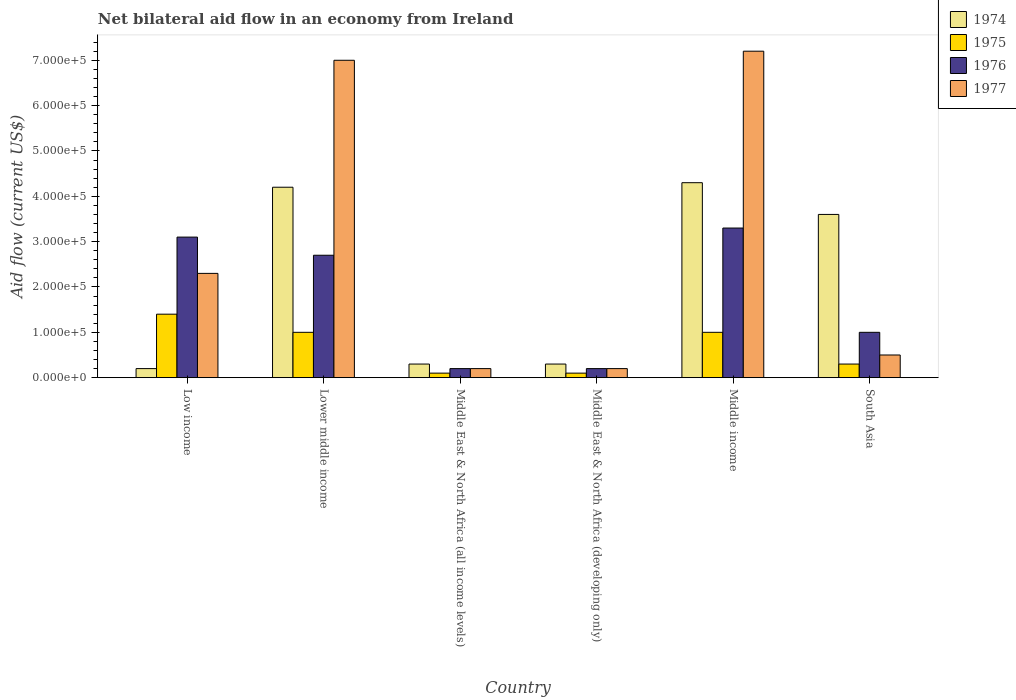How many different coloured bars are there?
Your answer should be compact. 4. How many groups of bars are there?
Offer a very short reply. 6. Are the number of bars per tick equal to the number of legend labels?
Your answer should be compact. Yes. Are the number of bars on each tick of the X-axis equal?
Keep it short and to the point. Yes. How many bars are there on the 6th tick from the right?
Offer a terse response. 4. What is the label of the 4th group of bars from the left?
Your answer should be very brief. Middle East & North Africa (developing only). What is the net bilateral aid flow in 1974 in Lower middle income?
Your response must be concise. 4.20e+05. Across all countries, what is the maximum net bilateral aid flow in 1975?
Give a very brief answer. 1.40e+05. In which country was the net bilateral aid flow in 1976 minimum?
Provide a succinct answer. Middle East & North Africa (all income levels). What is the total net bilateral aid flow in 1977 in the graph?
Provide a succinct answer. 1.74e+06. What is the average net bilateral aid flow in 1976 per country?
Offer a very short reply. 1.75e+05. What is the ratio of the net bilateral aid flow in 1976 in Middle East & North Africa (all income levels) to that in Middle income?
Keep it short and to the point. 0.06. Is the difference between the net bilateral aid flow in 1974 in Middle East & North Africa (developing only) and South Asia greater than the difference between the net bilateral aid flow in 1975 in Middle East & North Africa (developing only) and South Asia?
Make the answer very short. No. Is the sum of the net bilateral aid flow in 1975 in Middle East & North Africa (developing only) and South Asia greater than the maximum net bilateral aid flow in 1974 across all countries?
Ensure brevity in your answer.  No. What does the 4th bar from the left in Middle East & North Africa (all income levels) represents?
Your answer should be very brief. 1977. What does the 4th bar from the right in South Asia represents?
Provide a short and direct response. 1974. Is it the case that in every country, the sum of the net bilateral aid flow in 1976 and net bilateral aid flow in 1977 is greater than the net bilateral aid flow in 1975?
Your response must be concise. Yes. Are all the bars in the graph horizontal?
Offer a very short reply. No. What is the difference between two consecutive major ticks on the Y-axis?
Your response must be concise. 1.00e+05. Are the values on the major ticks of Y-axis written in scientific E-notation?
Your response must be concise. Yes. How many legend labels are there?
Provide a short and direct response. 4. What is the title of the graph?
Ensure brevity in your answer.  Net bilateral aid flow in an economy from Ireland. What is the label or title of the Y-axis?
Make the answer very short. Aid flow (current US$). What is the Aid flow (current US$) of 1976 in Low income?
Ensure brevity in your answer.  3.10e+05. What is the Aid flow (current US$) in 1974 in Lower middle income?
Your answer should be very brief. 4.20e+05. What is the Aid flow (current US$) of 1975 in Middle East & North Africa (all income levels)?
Ensure brevity in your answer.  10000. What is the Aid flow (current US$) of 1976 in Middle East & North Africa (all income levels)?
Your answer should be compact. 2.00e+04. What is the Aid flow (current US$) in 1977 in Middle East & North Africa (all income levels)?
Keep it short and to the point. 2.00e+04. What is the Aid flow (current US$) in 1976 in Middle East & North Africa (developing only)?
Your response must be concise. 2.00e+04. What is the Aid flow (current US$) of 1974 in Middle income?
Your answer should be compact. 4.30e+05. What is the Aid flow (current US$) in 1975 in Middle income?
Ensure brevity in your answer.  1.00e+05. What is the Aid flow (current US$) of 1976 in Middle income?
Give a very brief answer. 3.30e+05. What is the Aid flow (current US$) of 1977 in Middle income?
Offer a terse response. 7.20e+05. What is the Aid flow (current US$) in 1975 in South Asia?
Offer a terse response. 3.00e+04. What is the Aid flow (current US$) in 1976 in South Asia?
Your response must be concise. 1.00e+05. Across all countries, what is the maximum Aid flow (current US$) of 1977?
Provide a short and direct response. 7.20e+05. Across all countries, what is the minimum Aid flow (current US$) in 1974?
Your answer should be very brief. 2.00e+04. Across all countries, what is the minimum Aid flow (current US$) in 1976?
Your answer should be very brief. 2.00e+04. What is the total Aid flow (current US$) in 1974 in the graph?
Provide a succinct answer. 1.29e+06. What is the total Aid flow (current US$) in 1976 in the graph?
Your response must be concise. 1.05e+06. What is the total Aid flow (current US$) of 1977 in the graph?
Make the answer very short. 1.74e+06. What is the difference between the Aid flow (current US$) of 1974 in Low income and that in Lower middle income?
Your answer should be very brief. -4.00e+05. What is the difference between the Aid flow (current US$) in 1976 in Low income and that in Lower middle income?
Keep it short and to the point. 4.00e+04. What is the difference between the Aid flow (current US$) of 1977 in Low income and that in Lower middle income?
Offer a very short reply. -4.70e+05. What is the difference between the Aid flow (current US$) of 1975 in Low income and that in Middle East & North Africa (all income levels)?
Offer a very short reply. 1.30e+05. What is the difference between the Aid flow (current US$) in 1977 in Low income and that in Middle East & North Africa (all income levels)?
Give a very brief answer. 2.10e+05. What is the difference between the Aid flow (current US$) of 1974 in Low income and that in Middle income?
Keep it short and to the point. -4.10e+05. What is the difference between the Aid flow (current US$) in 1977 in Low income and that in Middle income?
Provide a short and direct response. -4.90e+05. What is the difference between the Aid flow (current US$) of 1975 in Low income and that in South Asia?
Make the answer very short. 1.10e+05. What is the difference between the Aid flow (current US$) in 1976 in Low income and that in South Asia?
Give a very brief answer. 2.10e+05. What is the difference between the Aid flow (current US$) of 1977 in Low income and that in South Asia?
Provide a short and direct response. 1.80e+05. What is the difference between the Aid flow (current US$) of 1976 in Lower middle income and that in Middle East & North Africa (all income levels)?
Provide a succinct answer. 2.50e+05. What is the difference between the Aid flow (current US$) in 1977 in Lower middle income and that in Middle East & North Africa (all income levels)?
Your answer should be compact. 6.80e+05. What is the difference between the Aid flow (current US$) in 1974 in Lower middle income and that in Middle East & North Africa (developing only)?
Make the answer very short. 3.90e+05. What is the difference between the Aid flow (current US$) in 1975 in Lower middle income and that in Middle East & North Africa (developing only)?
Your response must be concise. 9.00e+04. What is the difference between the Aid flow (current US$) of 1976 in Lower middle income and that in Middle East & North Africa (developing only)?
Keep it short and to the point. 2.50e+05. What is the difference between the Aid flow (current US$) in 1977 in Lower middle income and that in Middle East & North Africa (developing only)?
Make the answer very short. 6.80e+05. What is the difference between the Aid flow (current US$) of 1975 in Lower middle income and that in Middle income?
Provide a short and direct response. 0. What is the difference between the Aid flow (current US$) of 1976 in Lower middle income and that in South Asia?
Keep it short and to the point. 1.70e+05. What is the difference between the Aid flow (current US$) of 1977 in Lower middle income and that in South Asia?
Provide a succinct answer. 6.50e+05. What is the difference between the Aid flow (current US$) of 1975 in Middle East & North Africa (all income levels) and that in Middle East & North Africa (developing only)?
Your response must be concise. 0. What is the difference between the Aid flow (current US$) in 1976 in Middle East & North Africa (all income levels) and that in Middle East & North Africa (developing only)?
Offer a very short reply. 0. What is the difference between the Aid flow (current US$) of 1974 in Middle East & North Africa (all income levels) and that in Middle income?
Make the answer very short. -4.00e+05. What is the difference between the Aid flow (current US$) in 1976 in Middle East & North Africa (all income levels) and that in Middle income?
Your response must be concise. -3.10e+05. What is the difference between the Aid flow (current US$) in 1977 in Middle East & North Africa (all income levels) and that in Middle income?
Give a very brief answer. -7.00e+05. What is the difference between the Aid flow (current US$) in 1974 in Middle East & North Africa (all income levels) and that in South Asia?
Offer a very short reply. -3.30e+05. What is the difference between the Aid flow (current US$) in 1975 in Middle East & North Africa (all income levels) and that in South Asia?
Ensure brevity in your answer.  -2.00e+04. What is the difference between the Aid flow (current US$) in 1977 in Middle East & North Africa (all income levels) and that in South Asia?
Your answer should be very brief. -3.00e+04. What is the difference between the Aid flow (current US$) of 1974 in Middle East & North Africa (developing only) and that in Middle income?
Provide a short and direct response. -4.00e+05. What is the difference between the Aid flow (current US$) in 1975 in Middle East & North Africa (developing only) and that in Middle income?
Offer a terse response. -9.00e+04. What is the difference between the Aid flow (current US$) in 1976 in Middle East & North Africa (developing only) and that in Middle income?
Your answer should be very brief. -3.10e+05. What is the difference between the Aid flow (current US$) in 1977 in Middle East & North Africa (developing only) and that in Middle income?
Keep it short and to the point. -7.00e+05. What is the difference between the Aid flow (current US$) in 1974 in Middle East & North Africa (developing only) and that in South Asia?
Offer a terse response. -3.30e+05. What is the difference between the Aid flow (current US$) of 1977 in Middle East & North Africa (developing only) and that in South Asia?
Your response must be concise. -3.00e+04. What is the difference between the Aid flow (current US$) in 1975 in Middle income and that in South Asia?
Your answer should be compact. 7.00e+04. What is the difference between the Aid flow (current US$) of 1977 in Middle income and that in South Asia?
Offer a terse response. 6.70e+05. What is the difference between the Aid flow (current US$) in 1974 in Low income and the Aid flow (current US$) in 1976 in Lower middle income?
Offer a terse response. -2.50e+05. What is the difference between the Aid flow (current US$) of 1974 in Low income and the Aid flow (current US$) of 1977 in Lower middle income?
Your response must be concise. -6.80e+05. What is the difference between the Aid flow (current US$) in 1975 in Low income and the Aid flow (current US$) in 1977 in Lower middle income?
Your response must be concise. -5.60e+05. What is the difference between the Aid flow (current US$) of 1976 in Low income and the Aid flow (current US$) of 1977 in Lower middle income?
Your answer should be compact. -3.90e+05. What is the difference between the Aid flow (current US$) in 1974 in Low income and the Aid flow (current US$) in 1975 in Middle East & North Africa (all income levels)?
Offer a very short reply. 10000. What is the difference between the Aid flow (current US$) in 1974 in Low income and the Aid flow (current US$) in 1977 in Middle East & North Africa (all income levels)?
Offer a terse response. 0. What is the difference between the Aid flow (current US$) in 1976 in Low income and the Aid flow (current US$) in 1977 in Middle East & North Africa (all income levels)?
Offer a terse response. 2.90e+05. What is the difference between the Aid flow (current US$) of 1974 in Low income and the Aid flow (current US$) of 1975 in Middle East & North Africa (developing only)?
Your answer should be compact. 10000. What is the difference between the Aid flow (current US$) in 1974 in Low income and the Aid flow (current US$) in 1976 in Middle East & North Africa (developing only)?
Your answer should be compact. 0. What is the difference between the Aid flow (current US$) in 1974 in Low income and the Aid flow (current US$) in 1977 in Middle East & North Africa (developing only)?
Your response must be concise. 0. What is the difference between the Aid flow (current US$) in 1975 in Low income and the Aid flow (current US$) in 1976 in Middle East & North Africa (developing only)?
Your answer should be compact. 1.20e+05. What is the difference between the Aid flow (current US$) in 1975 in Low income and the Aid flow (current US$) in 1977 in Middle East & North Africa (developing only)?
Provide a short and direct response. 1.20e+05. What is the difference between the Aid flow (current US$) in 1976 in Low income and the Aid flow (current US$) in 1977 in Middle East & North Africa (developing only)?
Keep it short and to the point. 2.90e+05. What is the difference between the Aid flow (current US$) in 1974 in Low income and the Aid flow (current US$) in 1975 in Middle income?
Your answer should be compact. -8.00e+04. What is the difference between the Aid flow (current US$) in 1974 in Low income and the Aid flow (current US$) in 1976 in Middle income?
Ensure brevity in your answer.  -3.10e+05. What is the difference between the Aid flow (current US$) of 1974 in Low income and the Aid flow (current US$) of 1977 in Middle income?
Your answer should be very brief. -7.00e+05. What is the difference between the Aid flow (current US$) in 1975 in Low income and the Aid flow (current US$) in 1977 in Middle income?
Offer a very short reply. -5.80e+05. What is the difference between the Aid flow (current US$) of 1976 in Low income and the Aid flow (current US$) of 1977 in Middle income?
Your response must be concise. -4.10e+05. What is the difference between the Aid flow (current US$) of 1974 in Low income and the Aid flow (current US$) of 1975 in South Asia?
Provide a succinct answer. -10000. What is the difference between the Aid flow (current US$) in 1975 in Low income and the Aid flow (current US$) in 1976 in South Asia?
Your answer should be compact. 4.00e+04. What is the difference between the Aid flow (current US$) in 1975 in Low income and the Aid flow (current US$) in 1977 in South Asia?
Provide a succinct answer. 9.00e+04. What is the difference between the Aid flow (current US$) of 1976 in Low income and the Aid flow (current US$) of 1977 in South Asia?
Provide a succinct answer. 2.60e+05. What is the difference between the Aid flow (current US$) in 1974 in Lower middle income and the Aid flow (current US$) in 1976 in Middle East & North Africa (all income levels)?
Make the answer very short. 4.00e+05. What is the difference between the Aid flow (current US$) in 1975 in Lower middle income and the Aid flow (current US$) in 1976 in Middle East & North Africa (all income levels)?
Ensure brevity in your answer.  8.00e+04. What is the difference between the Aid flow (current US$) in 1974 in Lower middle income and the Aid flow (current US$) in 1975 in Middle East & North Africa (developing only)?
Offer a very short reply. 4.10e+05. What is the difference between the Aid flow (current US$) of 1974 in Lower middle income and the Aid flow (current US$) of 1976 in Middle East & North Africa (developing only)?
Your answer should be very brief. 4.00e+05. What is the difference between the Aid flow (current US$) of 1975 in Lower middle income and the Aid flow (current US$) of 1976 in Middle East & North Africa (developing only)?
Your response must be concise. 8.00e+04. What is the difference between the Aid flow (current US$) of 1975 in Lower middle income and the Aid flow (current US$) of 1977 in Middle East & North Africa (developing only)?
Provide a short and direct response. 8.00e+04. What is the difference between the Aid flow (current US$) of 1974 in Lower middle income and the Aid flow (current US$) of 1976 in Middle income?
Your answer should be very brief. 9.00e+04. What is the difference between the Aid flow (current US$) of 1975 in Lower middle income and the Aid flow (current US$) of 1977 in Middle income?
Ensure brevity in your answer.  -6.20e+05. What is the difference between the Aid flow (current US$) of 1976 in Lower middle income and the Aid flow (current US$) of 1977 in Middle income?
Your answer should be very brief. -4.50e+05. What is the difference between the Aid flow (current US$) in 1974 in Lower middle income and the Aid flow (current US$) in 1975 in South Asia?
Give a very brief answer. 3.90e+05. What is the difference between the Aid flow (current US$) of 1975 in Lower middle income and the Aid flow (current US$) of 1976 in South Asia?
Make the answer very short. 0. What is the difference between the Aid flow (current US$) of 1975 in Lower middle income and the Aid flow (current US$) of 1977 in South Asia?
Your answer should be very brief. 5.00e+04. What is the difference between the Aid flow (current US$) in 1976 in Lower middle income and the Aid flow (current US$) in 1977 in South Asia?
Ensure brevity in your answer.  2.20e+05. What is the difference between the Aid flow (current US$) of 1974 in Middle East & North Africa (all income levels) and the Aid flow (current US$) of 1975 in Middle East & North Africa (developing only)?
Offer a very short reply. 2.00e+04. What is the difference between the Aid flow (current US$) in 1975 in Middle East & North Africa (all income levels) and the Aid flow (current US$) in 1977 in Middle East & North Africa (developing only)?
Ensure brevity in your answer.  -10000. What is the difference between the Aid flow (current US$) of 1974 in Middle East & North Africa (all income levels) and the Aid flow (current US$) of 1977 in Middle income?
Offer a very short reply. -6.90e+05. What is the difference between the Aid flow (current US$) in 1975 in Middle East & North Africa (all income levels) and the Aid flow (current US$) in 1976 in Middle income?
Offer a terse response. -3.20e+05. What is the difference between the Aid flow (current US$) in 1975 in Middle East & North Africa (all income levels) and the Aid flow (current US$) in 1977 in Middle income?
Ensure brevity in your answer.  -7.10e+05. What is the difference between the Aid flow (current US$) of 1976 in Middle East & North Africa (all income levels) and the Aid flow (current US$) of 1977 in Middle income?
Your answer should be very brief. -7.00e+05. What is the difference between the Aid flow (current US$) in 1974 in Middle East & North Africa (all income levels) and the Aid flow (current US$) in 1975 in South Asia?
Keep it short and to the point. 0. What is the difference between the Aid flow (current US$) in 1974 in Middle East & North Africa (all income levels) and the Aid flow (current US$) in 1976 in South Asia?
Provide a short and direct response. -7.00e+04. What is the difference between the Aid flow (current US$) in 1974 in Middle East & North Africa (all income levels) and the Aid flow (current US$) in 1977 in South Asia?
Offer a very short reply. -2.00e+04. What is the difference between the Aid flow (current US$) in 1975 in Middle East & North Africa (all income levels) and the Aid flow (current US$) in 1976 in South Asia?
Your answer should be very brief. -9.00e+04. What is the difference between the Aid flow (current US$) of 1975 in Middle East & North Africa (all income levels) and the Aid flow (current US$) of 1977 in South Asia?
Your answer should be very brief. -4.00e+04. What is the difference between the Aid flow (current US$) of 1976 in Middle East & North Africa (all income levels) and the Aid flow (current US$) of 1977 in South Asia?
Ensure brevity in your answer.  -3.00e+04. What is the difference between the Aid flow (current US$) of 1974 in Middle East & North Africa (developing only) and the Aid flow (current US$) of 1975 in Middle income?
Your response must be concise. -7.00e+04. What is the difference between the Aid flow (current US$) of 1974 in Middle East & North Africa (developing only) and the Aid flow (current US$) of 1976 in Middle income?
Give a very brief answer. -3.00e+05. What is the difference between the Aid flow (current US$) of 1974 in Middle East & North Africa (developing only) and the Aid flow (current US$) of 1977 in Middle income?
Your response must be concise. -6.90e+05. What is the difference between the Aid flow (current US$) in 1975 in Middle East & North Africa (developing only) and the Aid flow (current US$) in 1976 in Middle income?
Your answer should be very brief. -3.20e+05. What is the difference between the Aid flow (current US$) in 1975 in Middle East & North Africa (developing only) and the Aid flow (current US$) in 1977 in Middle income?
Make the answer very short. -7.10e+05. What is the difference between the Aid flow (current US$) in 1976 in Middle East & North Africa (developing only) and the Aid flow (current US$) in 1977 in Middle income?
Offer a terse response. -7.00e+05. What is the difference between the Aid flow (current US$) in 1974 in Middle East & North Africa (developing only) and the Aid flow (current US$) in 1975 in South Asia?
Your answer should be very brief. 0. What is the difference between the Aid flow (current US$) in 1974 in Middle East & North Africa (developing only) and the Aid flow (current US$) in 1976 in South Asia?
Give a very brief answer. -7.00e+04. What is the difference between the Aid flow (current US$) of 1974 in Middle East & North Africa (developing only) and the Aid flow (current US$) of 1977 in South Asia?
Your response must be concise. -2.00e+04. What is the difference between the Aid flow (current US$) in 1975 in Middle income and the Aid flow (current US$) in 1976 in South Asia?
Your response must be concise. 0. What is the difference between the Aid flow (current US$) of 1975 in Middle income and the Aid flow (current US$) of 1977 in South Asia?
Keep it short and to the point. 5.00e+04. What is the average Aid flow (current US$) in 1974 per country?
Give a very brief answer. 2.15e+05. What is the average Aid flow (current US$) of 1975 per country?
Your answer should be compact. 6.50e+04. What is the average Aid flow (current US$) of 1976 per country?
Your answer should be very brief. 1.75e+05. What is the average Aid flow (current US$) in 1977 per country?
Your response must be concise. 2.90e+05. What is the difference between the Aid flow (current US$) in 1974 and Aid flow (current US$) in 1976 in Low income?
Offer a very short reply. -2.90e+05. What is the difference between the Aid flow (current US$) in 1974 and Aid flow (current US$) in 1977 in Low income?
Provide a short and direct response. -2.10e+05. What is the difference between the Aid flow (current US$) of 1975 and Aid flow (current US$) of 1976 in Low income?
Ensure brevity in your answer.  -1.70e+05. What is the difference between the Aid flow (current US$) of 1975 and Aid flow (current US$) of 1977 in Low income?
Keep it short and to the point. -9.00e+04. What is the difference between the Aid flow (current US$) in 1974 and Aid flow (current US$) in 1975 in Lower middle income?
Provide a succinct answer. 3.20e+05. What is the difference between the Aid flow (current US$) of 1974 and Aid flow (current US$) of 1977 in Lower middle income?
Make the answer very short. -2.80e+05. What is the difference between the Aid flow (current US$) of 1975 and Aid flow (current US$) of 1976 in Lower middle income?
Offer a terse response. -1.70e+05. What is the difference between the Aid flow (current US$) of 1975 and Aid flow (current US$) of 1977 in Lower middle income?
Your answer should be compact. -6.00e+05. What is the difference between the Aid flow (current US$) in 1976 and Aid flow (current US$) in 1977 in Lower middle income?
Your response must be concise. -4.30e+05. What is the difference between the Aid flow (current US$) in 1974 and Aid flow (current US$) in 1975 in Middle East & North Africa (all income levels)?
Ensure brevity in your answer.  2.00e+04. What is the difference between the Aid flow (current US$) of 1974 and Aid flow (current US$) of 1976 in Middle East & North Africa (all income levels)?
Offer a very short reply. 10000. What is the difference between the Aid flow (current US$) in 1975 and Aid flow (current US$) in 1977 in Middle East & North Africa (all income levels)?
Give a very brief answer. -10000. What is the difference between the Aid flow (current US$) in 1976 and Aid flow (current US$) in 1977 in Middle East & North Africa (all income levels)?
Ensure brevity in your answer.  0. What is the difference between the Aid flow (current US$) of 1974 and Aid flow (current US$) of 1975 in Middle East & North Africa (developing only)?
Your response must be concise. 2.00e+04. What is the difference between the Aid flow (current US$) of 1974 and Aid flow (current US$) of 1977 in Middle East & North Africa (developing only)?
Provide a short and direct response. 10000. What is the difference between the Aid flow (current US$) in 1975 and Aid flow (current US$) in 1976 in Middle East & North Africa (developing only)?
Provide a succinct answer. -10000. What is the difference between the Aid flow (current US$) in 1975 and Aid flow (current US$) in 1977 in Middle East & North Africa (developing only)?
Provide a succinct answer. -10000. What is the difference between the Aid flow (current US$) of 1976 and Aid flow (current US$) of 1977 in Middle East & North Africa (developing only)?
Keep it short and to the point. 0. What is the difference between the Aid flow (current US$) of 1974 and Aid flow (current US$) of 1976 in Middle income?
Offer a very short reply. 1.00e+05. What is the difference between the Aid flow (current US$) of 1975 and Aid flow (current US$) of 1976 in Middle income?
Your answer should be very brief. -2.30e+05. What is the difference between the Aid flow (current US$) in 1975 and Aid flow (current US$) in 1977 in Middle income?
Your answer should be very brief. -6.20e+05. What is the difference between the Aid flow (current US$) in 1976 and Aid flow (current US$) in 1977 in Middle income?
Offer a very short reply. -3.90e+05. What is the difference between the Aid flow (current US$) of 1974 and Aid flow (current US$) of 1975 in South Asia?
Offer a terse response. 3.30e+05. What is the difference between the Aid flow (current US$) in 1974 and Aid flow (current US$) in 1976 in South Asia?
Keep it short and to the point. 2.60e+05. What is the difference between the Aid flow (current US$) in 1975 and Aid flow (current US$) in 1976 in South Asia?
Your answer should be very brief. -7.00e+04. What is the ratio of the Aid flow (current US$) in 1974 in Low income to that in Lower middle income?
Offer a very short reply. 0.05. What is the ratio of the Aid flow (current US$) of 1975 in Low income to that in Lower middle income?
Make the answer very short. 1.4. What is the ratio of the Aid flow (current US$) in 1976 in Low income to that in Lower middle income?
Offer a terse response. 1.15. What is the ratio of the Aid flow (current US$) in 1977 in Low income to that in Lower middle income?
Ensure brevity in your answer.  0.33. What is the ratio of the Aid flow (current US$) of 1974 in Low income to that in Middle East & North Africa (all income levels)?
Provide a short and direct response. 0.67. What is the ratio of the Aid flow (current US$) of 1975 in Low income to that in Middle East & North Africa (all income levels)?
Offer a terse response. 14. What is the ratio of the Aid flow (current US$) in 1977 in Low income to that in Middle East & North Africa (developing only)?
Offer a terse response. 11.5. What is the ratio of the Aid flow (current US$) in 1974 in Low income to that in Middle income?
Offer a terse response. 0.05. What is the ratio of the Aid flow (current US$) of 1976 in Low income to that in Middle income?
Keep it short and to the point. 0.94. What is the ratio of the Aid flow (current US$) of 1977 in Low income to that in Middle income?
Provide a short and direct response. 0.32. What is the ratio of the Aid flow (current US$) in 1974 in Low income to that in South Asia?
Your answer should be compact. 0.06. What is the ratio of the Aid flow (current US$) in 1975 in Low income to that in South Asia?
Your answer should be compact. 4.67. What is the ratio of the Aid flow (current US$) of 1976 in Low income to that in South Asia?
Your response must be concise. 3.1. What is the ratio of the Aid flow (current US$) of 1976 in Lower middle income to that in Middle East & North Africa (all income levels)?
Ensure brevity in your answer.  13.5. What is the ratio of the Aid flow (current US$) of 1974 in Lower middle income to that in Middle East & North Africa (developing only)?
Make the answer very short. 14. What is the ratio of the Aid flow (current US$) in 1975 in Lower middle income to that in Middle East & North Africa (developing only)?
Keep it short and to the point. 10. What is the ratio of the Aid flow (current US$) of 1976 in Lower middle income to that in Middle East & North Africa (developing only)?
Your answer should be compact. 13.5. What is the ratio of the Aid flow (current US$) of 1977 in Lower middle income to that in Middle East & North Africa (developing only)?
Offer a terse response. 35. What is the ratio of the Aid flow (current US$) of 1974 in Lower middle income to that in Middle income?
Provide a short and direct response. 0.98. What is the ratio of the Aid flow (current US$) of 1975 in Lower middle income to that in Middle income?
Keep it short and to the point. 1. What is the ratio of the Aid flow (current US$) in 1976 in Lower middle income to that in Middle income?
Give a very brief answer. 0.82. What is the ratio of the Aid flow (current US$) in 1977 in Lower middle income to that in Middle income?
Provide a short and direct response. 0.97. What is the ratio of the Aid flow (current US$) in 1974 in Lower middle income to that in South Asia?
Offer a terse response. 1.17. What is the ratio of the Aid flow (current US$) of 1975 in Middle East & North Africa (all income levels) to that in Middle East & North Africa (developing only)?
Make the answer very short. 1. What is the ratio of the Aid flow (current US$) in 1977 in Middle East & North Africa (all income levels) to that in Middle East & North Africa (developing only)?
Keep it short and to the point. 1. What is the ratio of the Aid flow (current US$) of 1974 in Middle East & North Africa (all income levels) to that in Middle income?
Provide a succinct answer. 0.07. What is the ratio of the Aid flow (current US$) of 1975 in Middle East & North Africa (all income levels) to that in Middle income?
Offer a very short reply. 0.1. What is the ratio of the Aid flow (current US$) of 1976 in Middle East & North Africa (all income levels) to that in Middle income?
Give a very brief answer. 0.06. What is the ratio of the Aid flow (current US$) of 1977 in Middle East & North Africa (all income levels) to that in Middle income?
Your answer should be very brief. 0.03. What is the ratio of the Aid flow (current US$) of 1974 in Middle East & North Africa (all income levels) to that in South Asia?
Provide a short and direct response. 0.08. What is the ratio of the Aid flow (current US$) of 1975 in Middle East & North Africa (all income levels) to that in South Asia?
Provide a succinct answer. 0.33. What is the ratio of the Aid flow (current US$) in 1974 in Middle East & North Africa (developing only) to that in Middle income?
Your response must be concise. 0.07. What is the ratio of the Aid flow (current US$) of 1976 in Middle East & North Africa (developing only) to that in Middle income?
Your answer should be very brief. 0.06. What is the ratio of the Aid flow (current US$) in 1977 in Middle East & North Africa (developing only) to that in Middle income?
Offer a very short reply. 0.03. What is the ratio of the Aid flow (current US$) of 1974 in Middle East & North Africa (developing only) to that in South Asia?
Give a very brief answer. 0.08. What is the ratio of the Aid flow (current US$) in 1977 in Middle East & North Africa (developing only) to that in South Asia?
Your answer should be very brief. 0.4. What is the ratio of the Aid flow (current US$) of 1974 in Middle income to that in South Asia?
Make the answer very short. 1.19. What is the ratio of the Aid flow (current US$) in 1975 in Middle income to that in South Asia?
Your answer should be compact. 3.33. What is the ratio of the Aid flow (current US$) of 1977 in Middle income to that in South Asia?
Your answer should be compact. 14.4. What is the difference between the highest and the second highest Aid flow (current US$) in 1977?
Offer a terse response. 2.00e+04. What is the difference between the highest and the lowest Aid flow (current US$) in 1976?
Keep it short and to the point. 3.10e+05. 